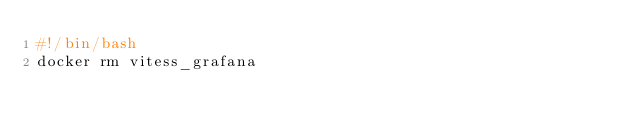<code> <loc_0><loc_0><loc_500><loc_500><_Bash_>#!/bin/bash
docker rm vitess_grafana
</code> 